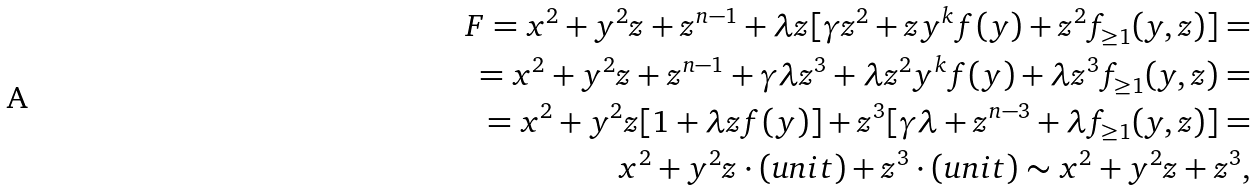Convert formula to latex. <formula><loc_0><loc_0><loc_500><loc_500>F = x ^ { 2 } + y ^ { 2 } z + z ^ { n - 1 } + \lambda z [ \gamma z ^ { 2 } + z y ^ { k } f ( y ) + z ^ { 2 } f _ { \geq 1 } ( y , z ) ] = \\ = x ^ { 2 } + y ^ { 2 } z + z ^ { n - 1 } + \gamma \lambda z ^ { 3 } + \lambda z ^ { 2 } y ^ { k } f ( y ) + \lambda z ^ { 3 } f _ { \geq 1 } ( y , z ) = \\ = x ^ { 2 } + y ^ { 2 } z [ 1 + \lambda z f ( y ) ] + z ^ { 3 } [ \gamma \lambda + z ^ { n - 3 } + \lambda f _ { \geq 1 } ( y , z ) ] = \\ x ^ { 2 } + y ^ { 2 } z \cdot ( u n i t ) + z ^ { 3 } \cdot ( u n i t ) \sim x ^ { 2 } + y ^ { 2 } z + z ^ { 3 } ,</formula> 